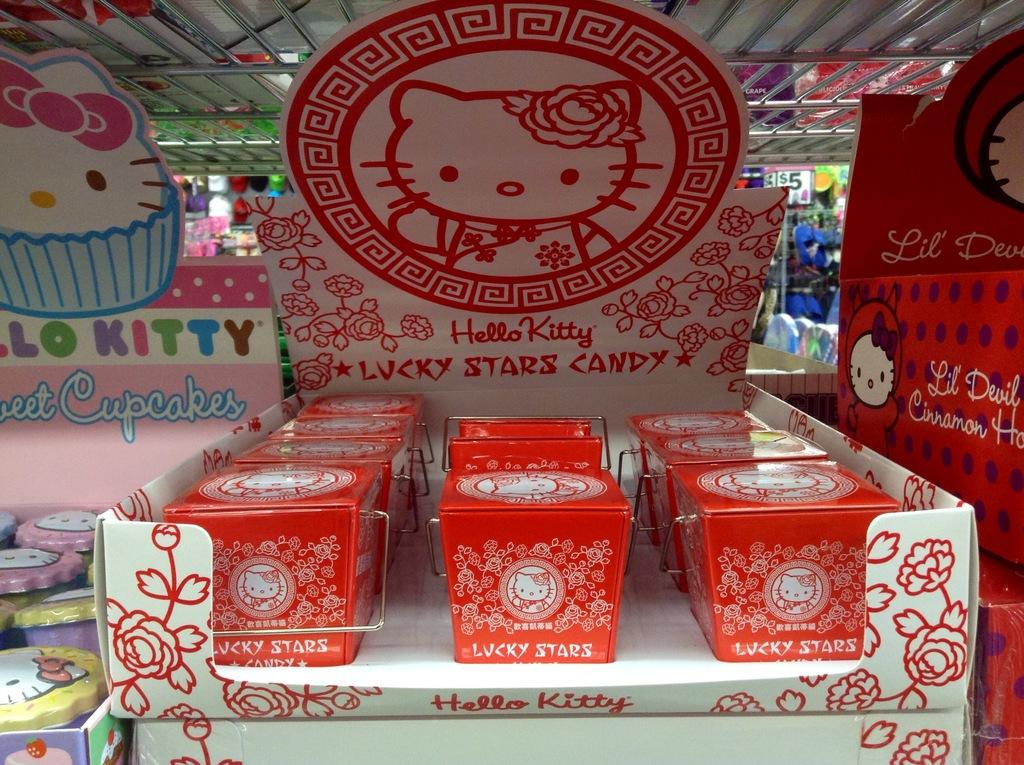<image>
Relay a brief, clear account of the picture shown. A display of Hello Kitty products are on a table. 